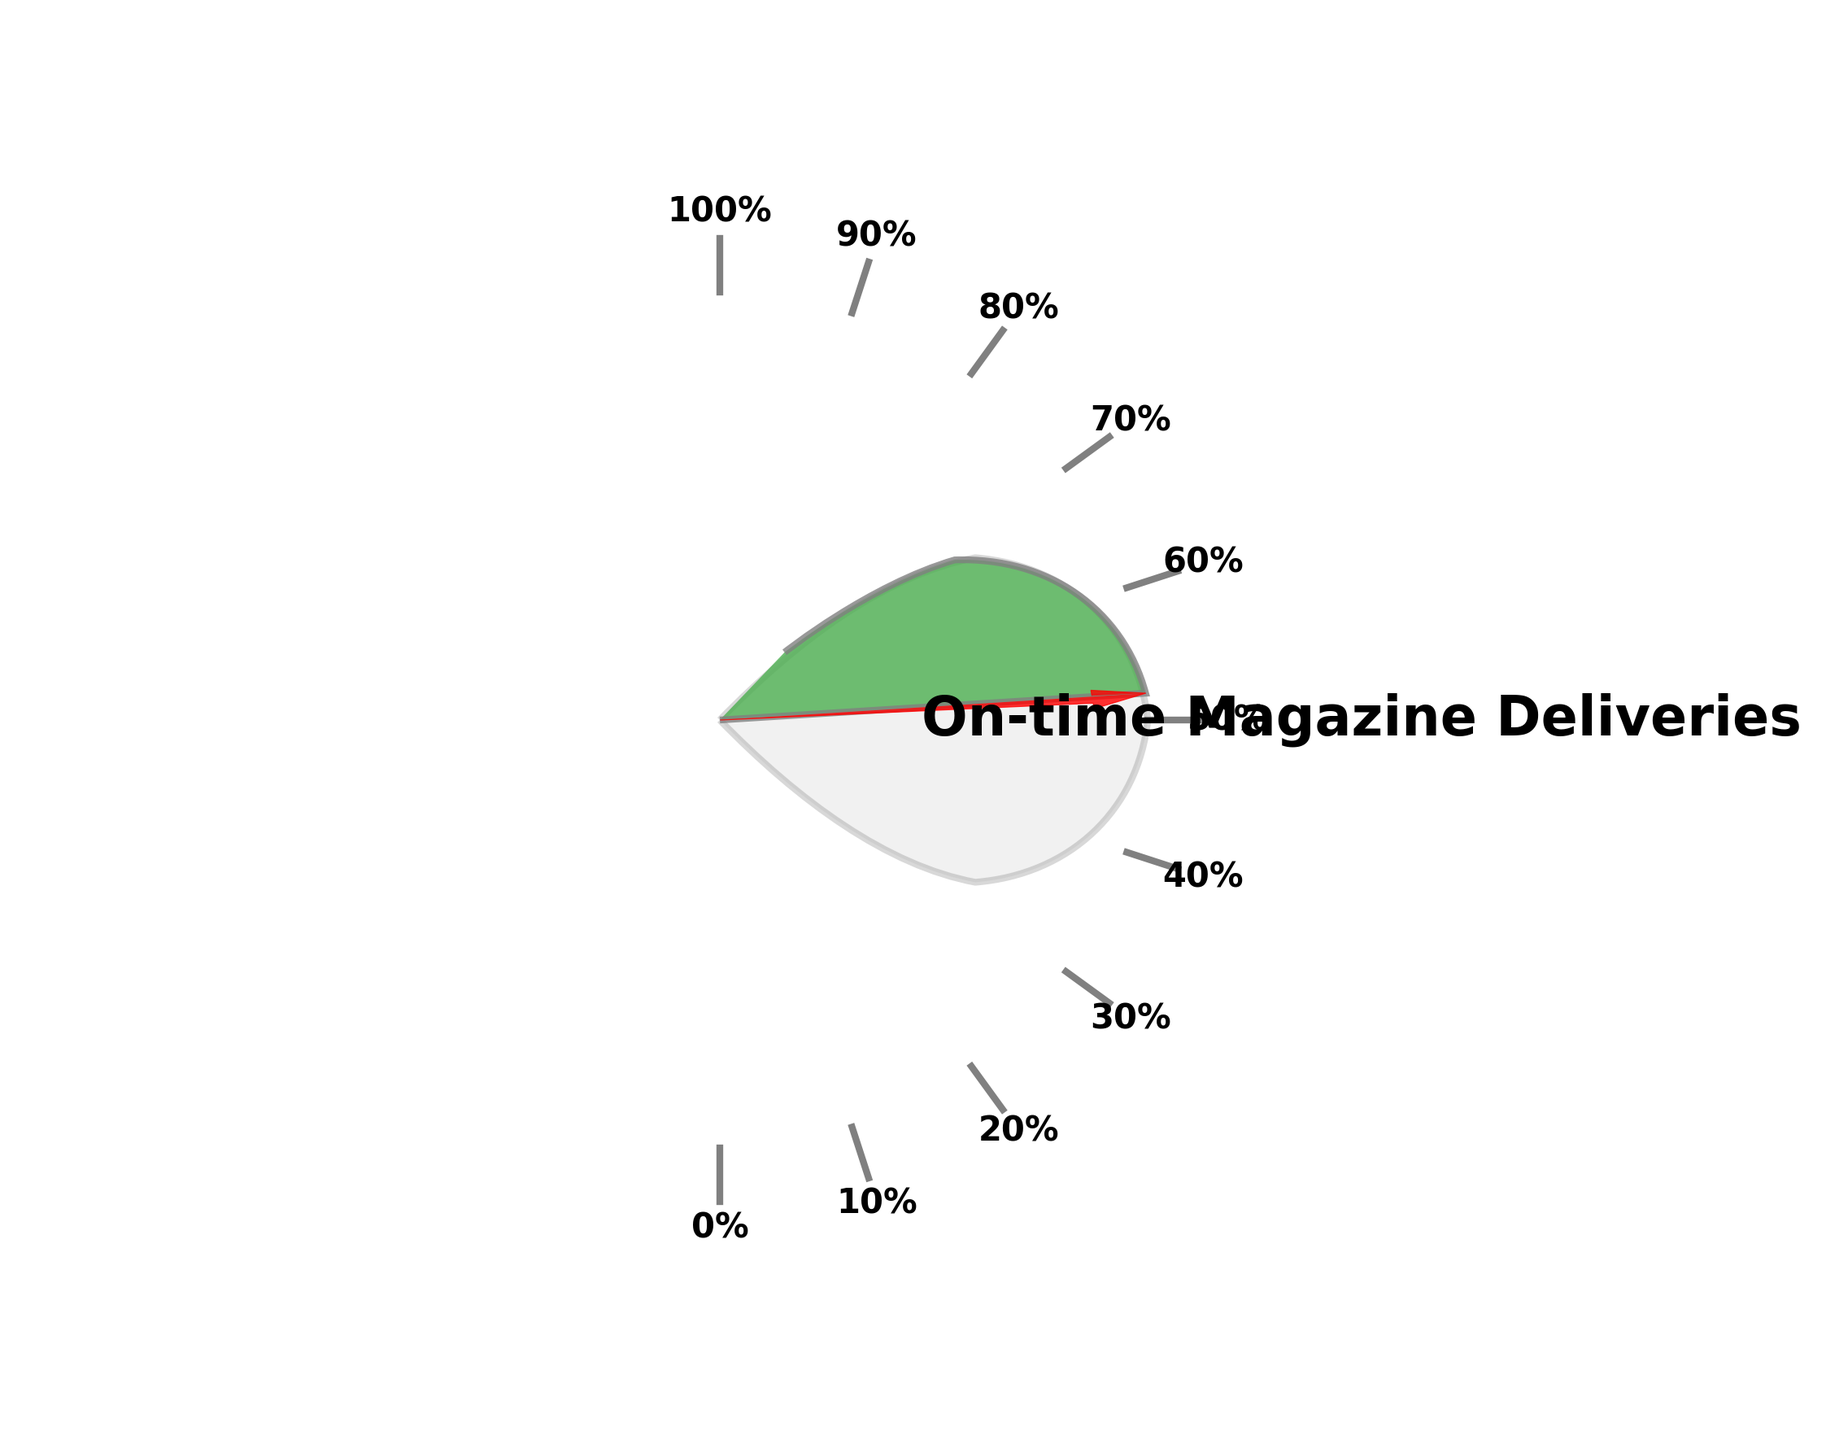What is the title of the gauge chart? The title of the gauge chart is written at the top of the figure with a larger font size and bold styling. The title provides context about what the gauge chart is measuring.
Answer: On-time Magazine Deliveries What is the percentage of on-time magazine deliveries shown on the gauge chart? The percentage value is displayed near the center of the gauge with a large font size and in bold.
Answer: 97.5% What is the target percentage for on-time magazine deliveries? The target percentage is implied by the total span of the gauge, which is labeled from 0% to 100%. Since the gauge reaches 97.5% out of 100%, the target is 100%.
Answer: 100% Is the current percentage of on-time deliveries higher or lower than the target? The current percentage (97.5%) is compared to the target (100%), and it is evident that 97.5% is lower than 100%.
Answer: Lower How many tick marks are there in the gauge chart from start to end? The gauge chart has tick marks labeled from 0% to 100%, increasing by 10% each time, resulting in 11 tick marks in total.
Answer: 11 What color represents the filled portion of the gauge? The filled portion of the gauge is visually represented by the color green, which indicates the percentage of on-time deliveries.
Answer: Green What angle does the needle point to on the gauge? The needle represents the 97.5% value and points to an angle slightly less than 180 degrees (horizontal), which corresponds to the percentage of 97.5%.
Answer: Slightly less than 180 degrees How much lower is the current percentage from the target percentage in absolute value? To find how much lower the current percentage (97.5%) is from the target (100%), subtract 97.5 from 100 to get the difference.
Answer: 2.5% What is the primary purpose of the red arrow (needle) in the gauge chart? The primary purpose of the red arrow (needle) is to visually indicate the exact current percentage of on-time magazine deliveries on the gauge.
Answer: To indicate the exact percentage What is the color of the background circle in the gauge chart? The background circle is a light gray color, which serves to visually support the main elements of the gauge without drawing too much attention.
Answer: Light gray 